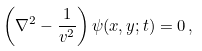Convert formula to latex. <formula><loc_0><loc_0><loc_500><loc_500>\left ( \nabla ^ { 2 } - \frac { 1 } { v ^ { 2 } } \right ) \psi ( x , y ; t ) = 0 \, ,</formula> 